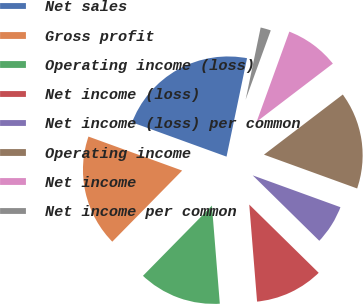<chart> <loc_0><loc_0><loc_500><loc_500><pie_chart><fcel>Net sales<fcel>Gross profit<fcel>Operating income (loss)<fcel>Net income (loss)<fcel>Net income (loss) per common<fcel>Operating income<fcel>Net income<fcel>Net income per common<nl><fcel>22.73%<fcel>18.18%<fcel>13.64%<fcel>11.36%<fcel>6.82%<fcel>15.91%<fcel>9.09%<fcel>2.27%<nl></chart> 